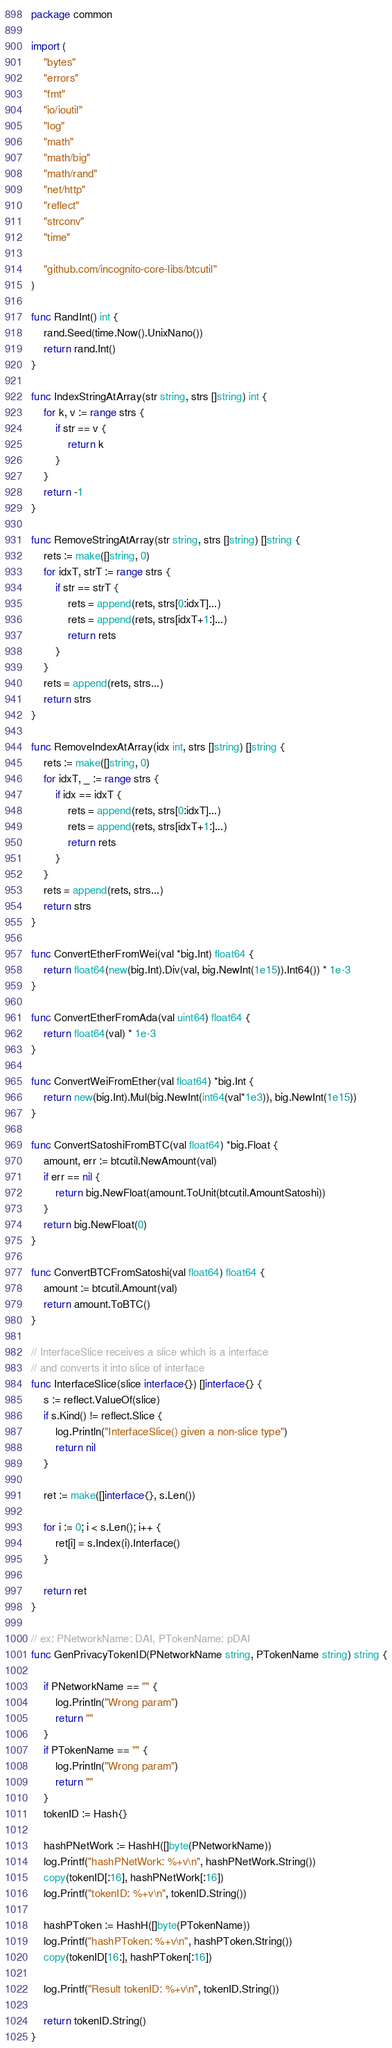Convert code to text. <code><loc_0><loc_0><loc_500><loc_500><_Go_>package common

import (
	"bytes"
	"errors"
	"fmt"
	"io/ioutil"
	"log"
	"math"
	"math/big"
	"math/rand"
	"net/http"
	"reflect"
	"strconv"
	"time"

	"github.com/incognito-core-libs/btcutil"
)

func RandInt() int {
	rand.Seed(time.Now().UnixNano())
	return rand.Int()
}

func IndexStringAtArray(str string, strs []string) int {
	for k, v := range strs {
		if str == v {
			return k
		}
	}
	return -1
}

func RemoveStringAtArray(str string, strs []string) []string {
	rets := make([]string, 0)
	for idxT, strT := range strs {
		if str == strT {
			rets = append(rets, strs[0:idxT]...)
			rets = append(rets, strs[idxT+1:]...)
			return rets
		}
	}
	rets = append(rets, strs...)
	return strs
}

func RemoveIndexAtArray(idx int, strs []string) []string {
	rets := make([]string, 0)
	for idxT, _ := range strs {
		if idx == idxT {
			rets = append(rets, strs[0:idxT]...)
			rets = append(rets, strs[idxT+1:]...)
			return rets
		}
	}
	rets = append(rets, strs...)
	return strs
}

func ConvertEtherFromWei(val *big.Int) float64 {
	return float64(new(big.Int).Div(val, big.NewInt(1e15)).Int64()) * 1e-3
}

func ConvertEtherFromAda(val uint64) float64 {
	return float64(val) * 1e-3
}

func ConvertWeiFromEther(val float64) *big.Int {
	return new(big.Int).Mul(big.NewInt(int64(val*1e3)), big.NewInt(1e15))
}

func ConvertSatoshiFromBTC(val float64) *big.Float {
	amount, err := btcutil.NewAmount(val)
	if err == nil {
		return big.NewFloat(amount.ToUnit(btcutil.AmountSatoshi))
	}
	return big.NewFloat(0)
}

func ConvertBTCFromSatoshi(val float64) float64 {
	amount := btcutil.Amount(val)
	return amount.ToBTC()
}

// InterfaceSlice receives a slice which is a interface
// and converts it into slice of interface
func InterfaceSlice(slice interface{}) []interface{} {
	s := reflect.ValueOf(slice)
	if s.Kind() != reflect.Slice {
		log.Println("InterfaceSlice() given a non-slice type")
		return nil
	}

	ret := make([]interface{}, s.Len())

	for i := 0; i < s.Len(); i++ {
		ret[i] = s.Index(i).Interface()
	}

	return ret
}

// ex: PNetworkName: DAI, PTokenName: pDAI
func GenPrivacyTokenID(PNetworkName string, PTokenName string) string {

	if PNetworkName == "" {
		log.Println("Wrong param")
		return ""
	}
	if PTokenName == "" {
		log.Println("Wrong param")
		return ""
	}
	tokenID := Hash{}

	hashPNetWork := HashH([]byte(PNetworkName))
	log.Printf("hashPNetWork: %+v\n", hashPNetWork.String())
	copy(tokenID[:16], hashPNetWork[:16])
	log.Printf("tokenID: %+v\n", tokenID.String())

	hashPToken := HashH([]byte(PTokenName))
	log.Printf("hashPToken: %+v\n", hashPToken.String())
	copy(tokenID[16:], hashPToken[:16])

	log.Printf("Result tokenID: %+v\n", tokenID.String())

	return tokenID.String()
}
</code> 